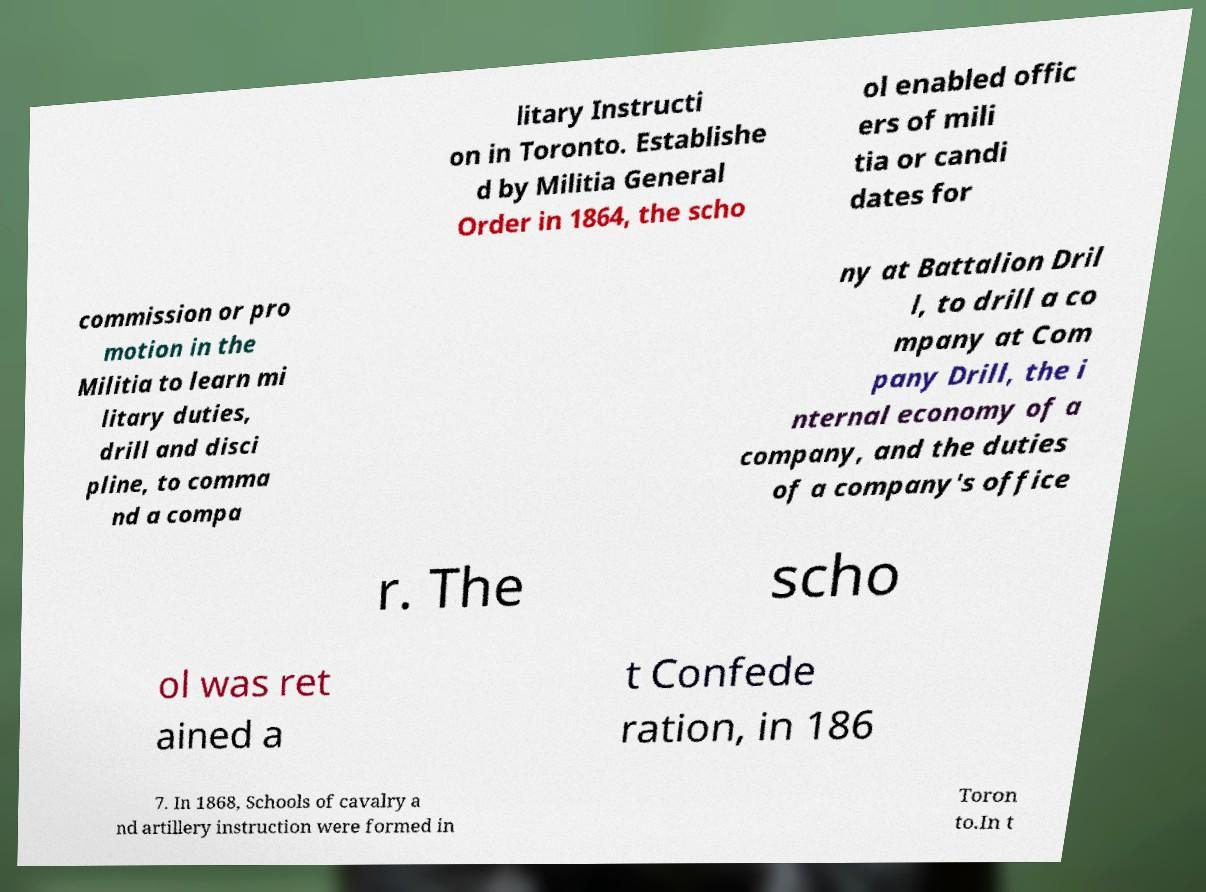Could you extract and type out the text from this image? litary Instructi on in Toronto. Establishe d by Militia General Order in 1864, the scho ol enabled offic ers of mili tia or candi dates for commission or pro motion in the Militia to learn mi litary duties, drill and disci pline, to comma nd a compa ny at Battalion Dril l, to drill a co mpany at Com pany Drill, the i nternal economy of a company, and the duties of a company's office r. The scho ol was ret ained a t Confede ration, in 186 7. In 1868, Schools of cavalry a nd artillery instruction were formed in Toron to.In t 